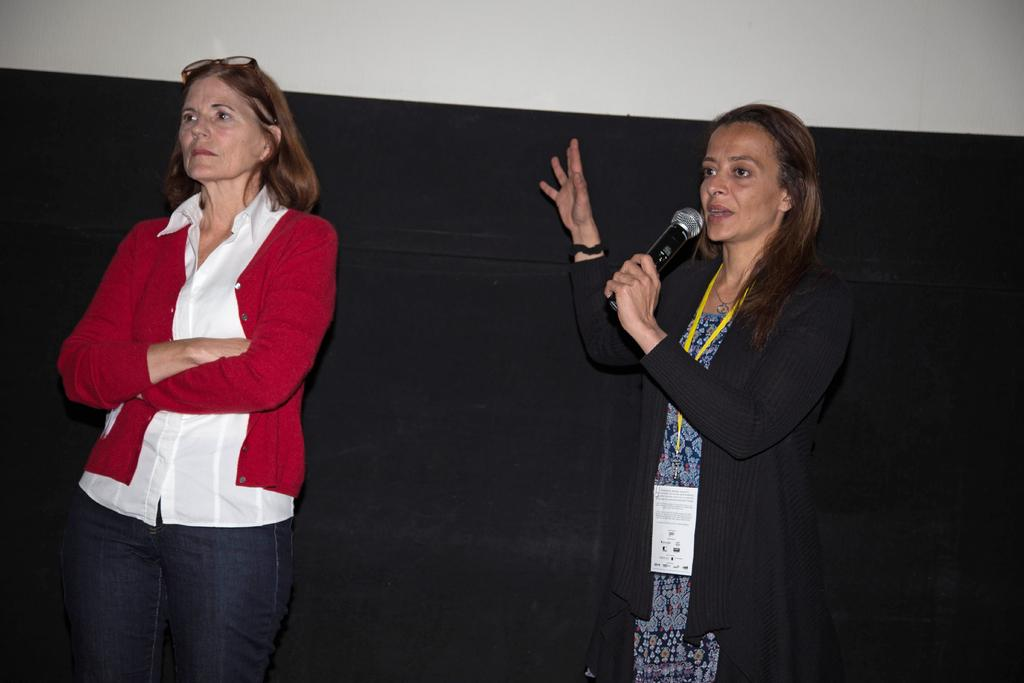How many people are in the image? There are two women standing in the image. What is one of the women holding? One of the women is holding a microphone. What is the woman holding the microphone doing? The woman holding the microphone is talking. What can be seen in the background of the image? There is a black-colored wall in the background of the image. Can you see the women kicking a soccer ball in the image? No, there is no soccer ball or any indication of kicking in the image. 